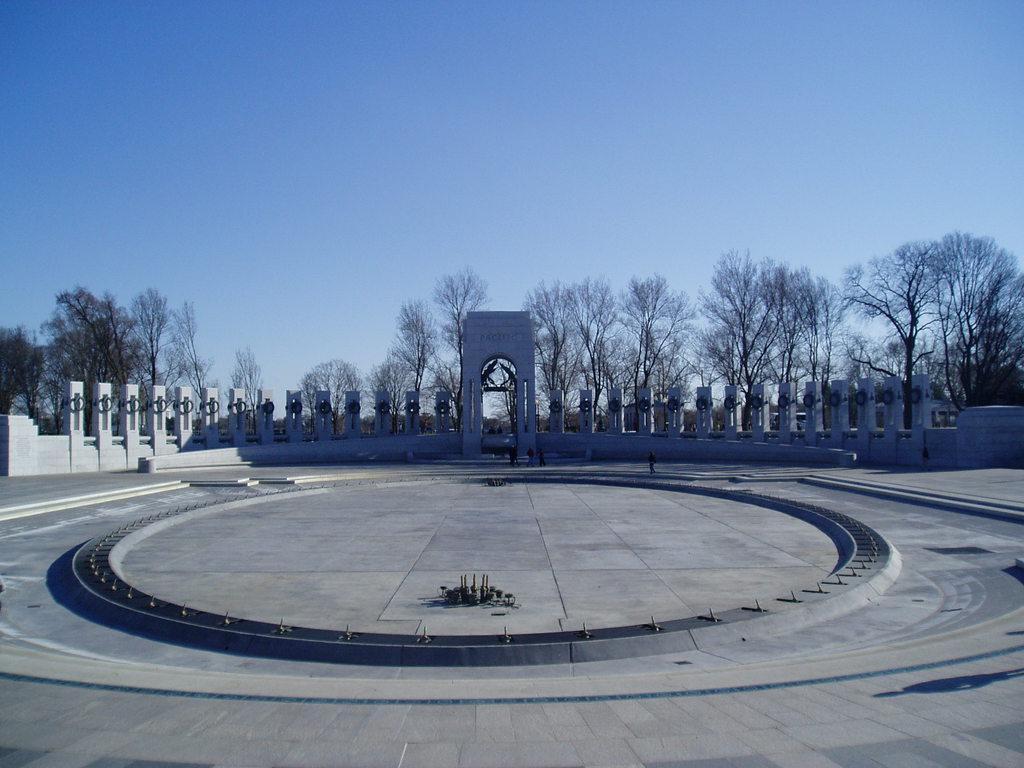Describe this image in one or two sentences. This picture is clicked outside. In the foreground we can see the ground and some objects and we can see the group of people and the pillars. In the background we can see the sky, trees and we can see some objects seems to be the sculptures and we can see many other objects. 